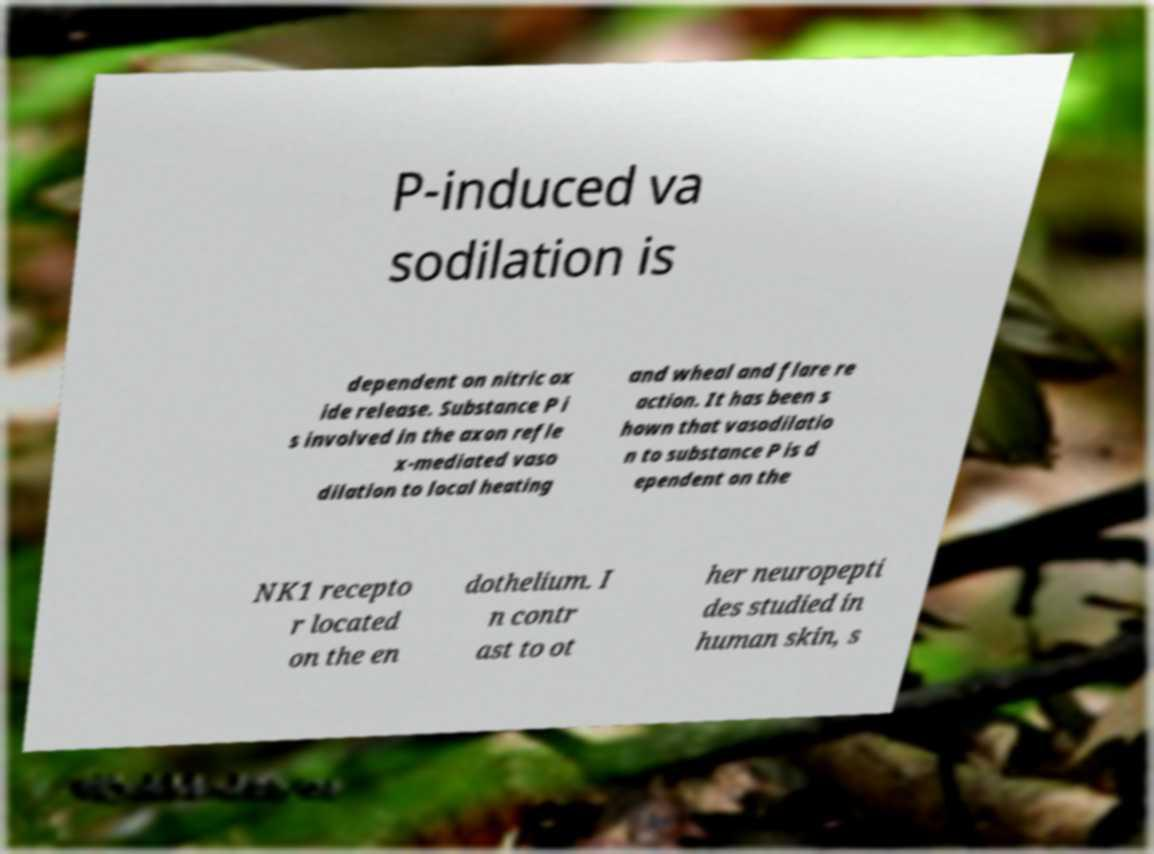Please identify and transcribe the text found in this image. P-induced va sodilation is dependent on nitric ox ide release. Substance P i s involved in the axon refle x-mediated vaso dilation to local heating and wheal and flare re action. It has been s hown that vasodilatio n to substance P is d ependent on the NK1 recepto r located on the en dothelium. I n contr ast to ot her neuropepti des studied in human skin, s 